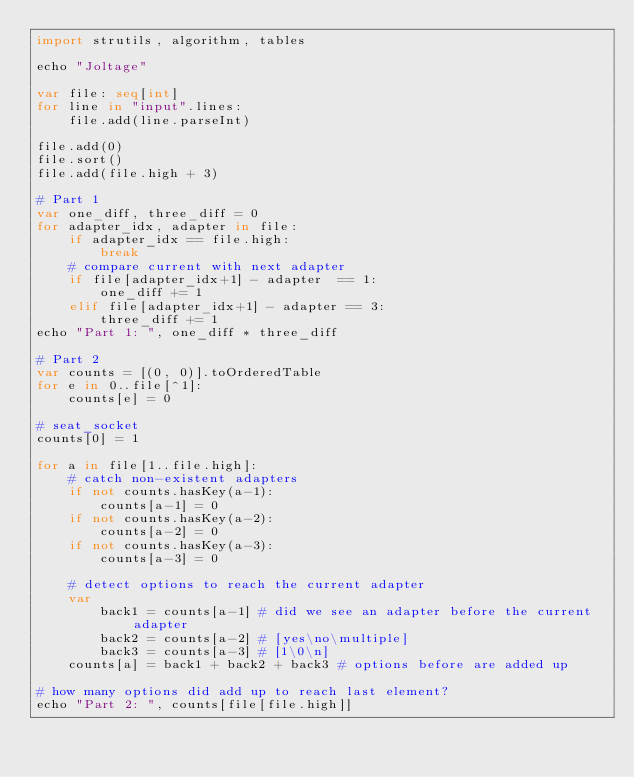<code> <loc_0><loc_0><loc_500><loc_500><_Nim_>import strutils, algorithm, tables

echo "Joltage"

var file: seq[int]
for line in "input".lines:
    file.add(line.parseInt)

file.add(0)
file.sort()
file.add(file.high + 3)

# Part 1
var one_diff, three_diff = 0
for adapter_idx, adapter in file:
    if adapter_idx == file.high: 
        break
    # compare current with next adapter
    if file[adapter_idx+1] - adapter  == 1:
        one_diff += 1
    elif file[adapter_idx+1] - adapter == 3:
        three_diff += 1
echo "Part 1: ", one_diff * three_diff

# Part 2
var counts = [(0, 0)].toOrderedTable
for e in 0..file[^1]:
    counts[e] = 0

# seat_socket
counts[0] = 1 

for a in file[1..file.high]:
    # catch non-existent adapters
    if not counts.hasKey(a-1):
        counts[a-1] = 0
    if not counts.hasKey(a-2):
        counts[a-2] = 0
    if not counts.hasKey(a-3):
        counts[a-3] = 0

    # detect options to reach the current adapter
    var
        back1 = counts[a-1] # did we see an adapter before the current adapter 
        back2 = counts[a-2] # [yes\no\multiple]
        back3 = counts[a-3] # [1\0\n]
    counts[a] = back1 + back2 + back3 # options before are added up

# how many options did add up to reach last element?
echo "Part 2: ", counts[file[file.high]]</code> 